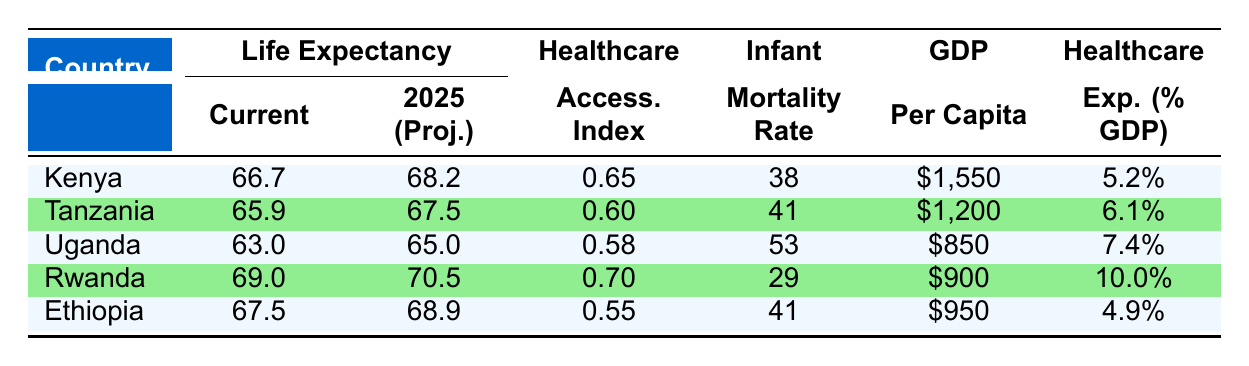What is the projected life expectancy for Kenya in 2025? The table states that the projected life expectancy for Kenya in 2025 is 68.2.
Answer: 68.2 Which country has the highest healthcare accessibility index? By examining the healthcare accessibility index for each country, Rwanda has the highest value at 0.70.
Answer: Rwanda What is the difference in current life expectancy between Tanzania and Uganda? Tanzania's current life expectancy is 65.9, while Uganda's is 63.0. Therefore, the difference is 65.9 - 63.0 = 2.9.
Answer: 2.9 Is the healthcare expenditure as a percentage of GDP higher in Ethiopia than in Kenya? Ethiopia's healthcare expenditure as a percentage of GDP is 4.9% and Kenya's is 5.2%. Since 4.9% is less than 5.2%, the statement is false.
Answer: No What is the average projected life expectancy for the five countries in 2025? To find the average, sum the projected life expectancies: (68.2 + 67.5 + 65.0 + 70.5 + 68.9) = 340.1. Then divide by 5, which gives 340.1 / 5 = 68.02.
Answer: 68.02 Which country has the lowest infant mortality rate, and what is the rate? The infant mortality rate for each country is as follows: Kenya (38), Tanzania (41), Uganda (53), Rwanda (29), and Ethiopia (41). Rwanda has the lowest rate at 29.
Answer: Rwanda; 29 If you combine the GDP per capita of Kenya and Rwanda, what is the total? Kenya's GDP per capita is $1,550, and Rwanda's is $900. Adding them together gives $1,550 + $900 = $2,450.
Answer: $2,450 Is the current life expectancy for Uganda above the average current life expectancy of the East African countries listed? The current life expectancies are: Kenya (66.7), Tanzania (65.9), Uganda (63.0), Rwanda (69.0), and Ethiopia (67.5). The average current life expectancy is (66.7 + 65.9 + 63.0 + 69.0 + 67.5) / 5 = 66.42. Since 63.0 is less than 66.42, the statement is false.
Answer: No 